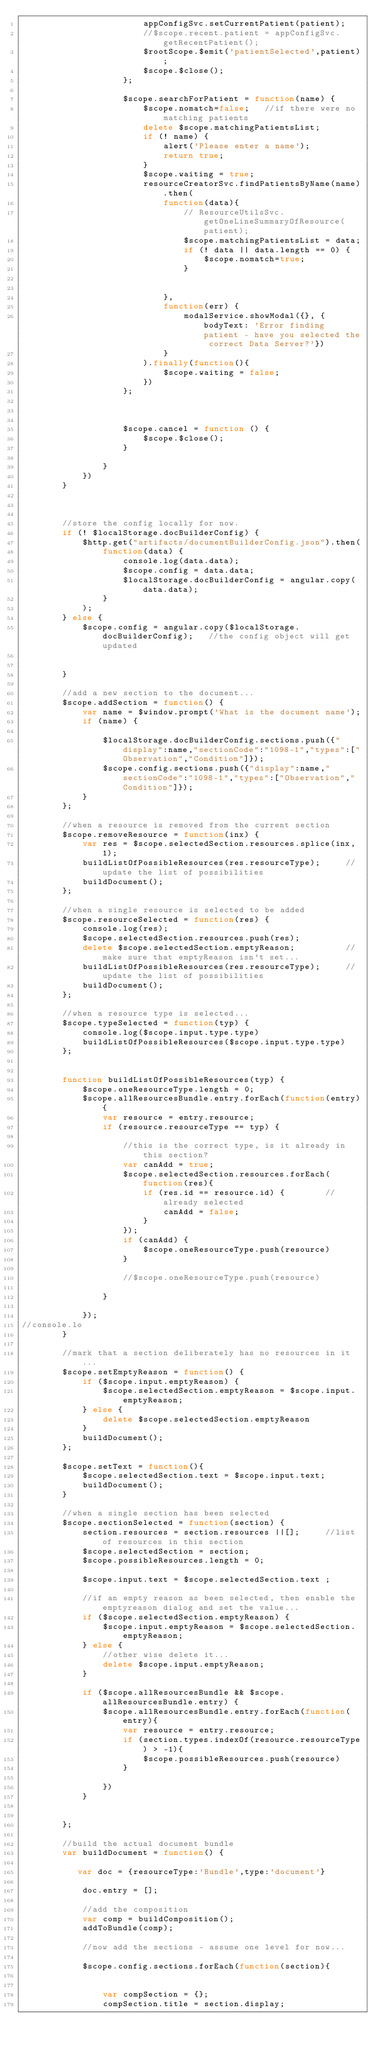Convert code to text. <code><loc_0><loc_0><loc_500><loc_500><_JavaScript_>                        appConfigSvc.setCurrentPatient(patient);
                        //$scope.recent.patient = appConfigSvc.getRecentPatient();
                        $rootScope.$emit('patientSelected',patient);
                        $scope.$close();
                    };

                    $scope.searchForPatient = function(name) {
                        $scope.nomatch=false;   //if there were no matching patients
                        delete $scope.matchingPatientsList;
                        if (! name) {
                            alert('Please enter a name');
                            return true;
                        }
                        $scope.waiting = true;
                        resourceCreatorSvc.findPatientsByName(name).then(
                            function(data){
                                // ResourceUtilsSvc.getOneLineSummaryOfResource(patient);
                                $scope.matchingPatientsList = data;
                                if (! data || data.length == 0) {
                                    $scope.nomatch=true;
                                }


                            },
                            function(err) {
                                modalService.showModal({}, {bodyText: 'Error finding patient - have you selected the correct Data Server?'})
                            }
                        ).finally(function(){
                            $scope.waiting = false;
                        })
                    };



                    $scope.cancel = function () {
                        $scope.$close();
                    }

                }
            })
        }


        
        //store the config locally for now.
        if (! $localStorage.docBuilderConfig) {
            $http.get("artifacts/documentBuilderConfig.json").then(
                function(data) {
                    console.log(data.data);
                    $scope.config = data.data;
                    $localStorage.docBuilderConfig = angular.copy(data.data);
                }
            );
        } else {
            $scope.config = angular.copy($localStorage.docBuilderConfig);   //the config object will get updated


        }
        
        //add a new section to the document...
        $scope.addSection = function() {
            var name = $window.prompt('What is the document name');
            if (name) {

                $localStorage.docBuilderConfig.sections.push({"display":name,"sectionCode":"1098-1","types":["Observation","Condition"]});
                $scope.config.sections.push({"display":name,"sectionCode":"1098-1","types":["Observation","Condition"]});
            }
        };

        //when a resource is removed from the current section
        $scope.removeResource = function(inx) {
            var res = $scope.selectedSection.resources.splice(inx, 1);
            buildListOfPossibleResources(res.resourceType);     //update the list of possibilities
            buildDocument();
        };

        //when a single resource is selected to be added
        $scope.resourceSelected = function(res) {
            console.log(res);
            $scope.selectedSection.resources.push(res);
            delete $scope.selectedSection.emptyReason;          //make sure that emptyReason isn't set...
            buildListOfPossibleResources(res.resourceType);     //update the list of possibilities
            buildDocument();
        };

        //when a resource type is selected...
        $scope.typeSelected = function(typ) {
            console.log($scope.input.type.type)
            buildListOfPossibleResources($scope.input.type.type)
        };


        function buildListOfPossibleResources(typ) {
            $scope.oneResourceType.length = 0;
            $scope.allResourcesBundle.entry.forEach(function(entry){
                var resource = entry.resource;
                if (resource.resourceType == typ) {

                    //this is the correct type, is it already in this section?
                    var canAdd = true;
                    $scope.selectedSection.resources.forEach(function(res){
                        if (res.id == resource.id) {        //already selected
                            canAdd = false;
                        }
                    });
                    if (canAdd) {
                        $scope.oneResourceType.push(resource)
                    }

                    //$scope.oneResourceType.push(resource)

                }

            });
//console.lo
        }

        //mark that a section deliberately has no resources in it...
        $scope.setEmptyReason = function() {
            if ($scope.input.emptyReason) {
                $scope.selectedSection.emptyReason = $scope.input.emptyReason;
            } else {
                delete $scope.selectedSection.emptyReason
            }
            buildDocument();
        };

        $scope.setText = function(){
            $scope.selectedSection.text = $scope.input.text;
            buildDocument();
        }

        //when a single section has been selected
        $scope.sectionSelected = function(section) {
            section.resources = section.resources ||[];     //list of resources in this section
            $scope.selectedSection = section;
            $scope.possibleResources.length = 0;

            $scope.input.text = $scope.selectedSection.text ;

            //if an empty reason as been selected, then enable the emptyreason dialog and set the value...
            if ($scope.selectedSection.emptyReason) {
                $scope.input.emptyReason = $scope.selectedSection.emptyReason;
            } else {
                //other wise delete it...
                delete $scope.input.emptyReason;
            }
            
            if ($scope.allResourcesBundle && $scope.allResourcesBundle.entry) {
                $scope.allResourcesBundle.entry.forEach(function(entry){
                    var resource = entry.resource;
                    if (section.types.indexOf(resource.resourceType) > -1){
                        $scope.possibleResources.push(resource)
                    }

                })
            }

            
        };

        //build the actual document bundle
        var buildDocument = function() {

           var doc = {resourceType:'Bundle',type:'document'}

            doc.entry = [];

            //add the composition
            var comp = buildComposition();
            addToBundle(comp);

            //now add the sections - assume one level for now...

            $scope.config.sections.forEach(function(section){


                var compSection = {};
                compSection.title = section.display;</code> 